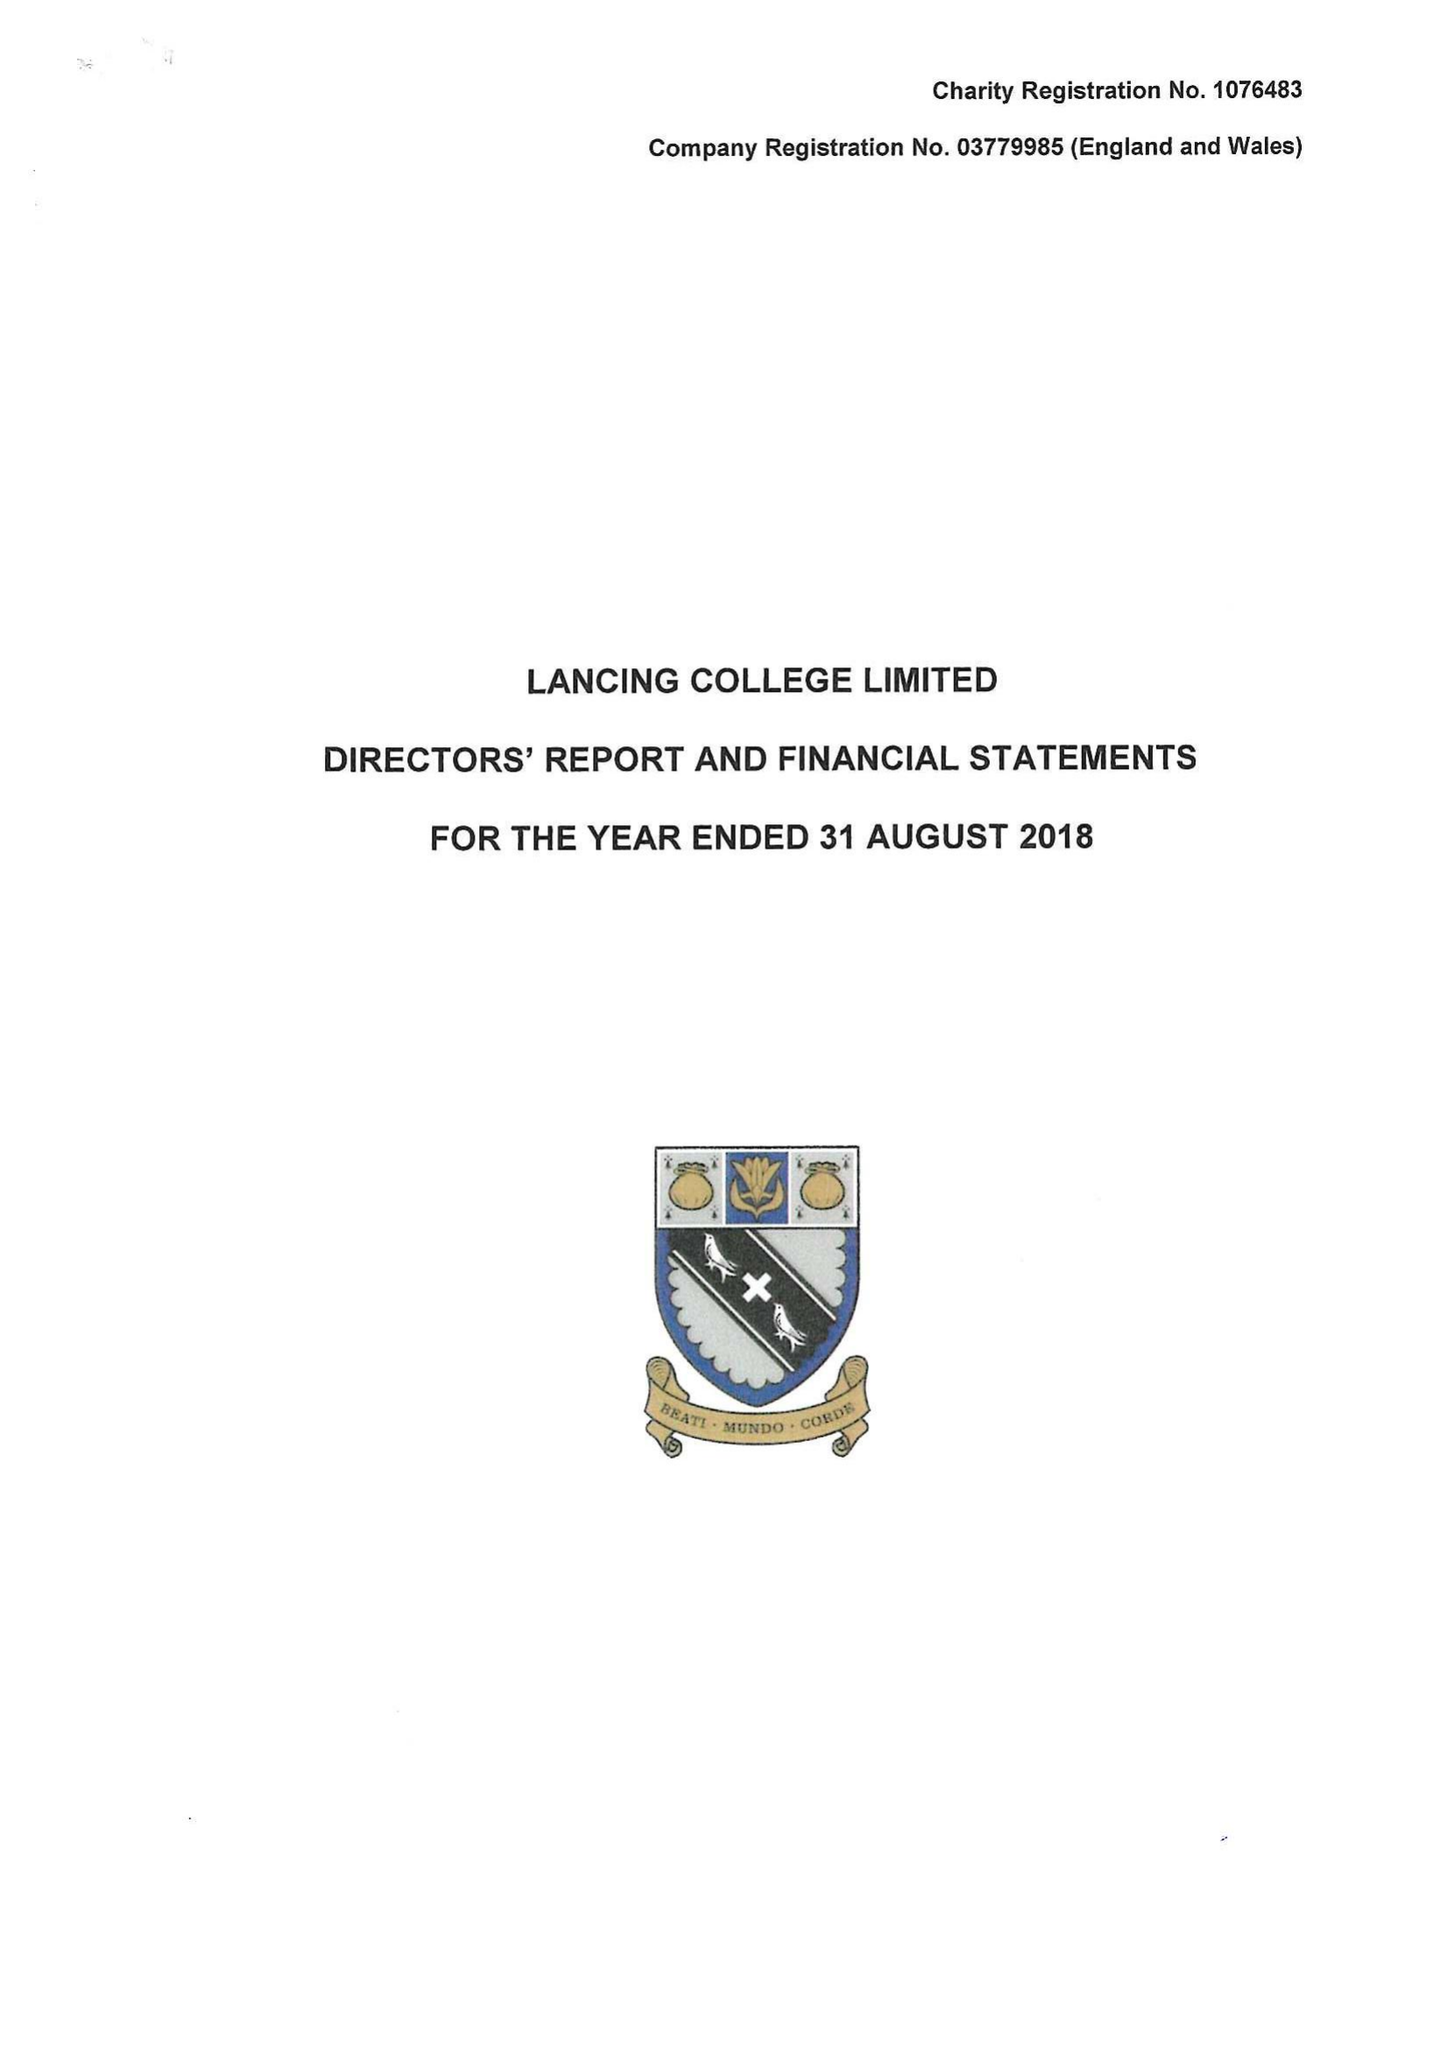What is the value for the address__street_line?
Answer the question using a single word or phrase. None 